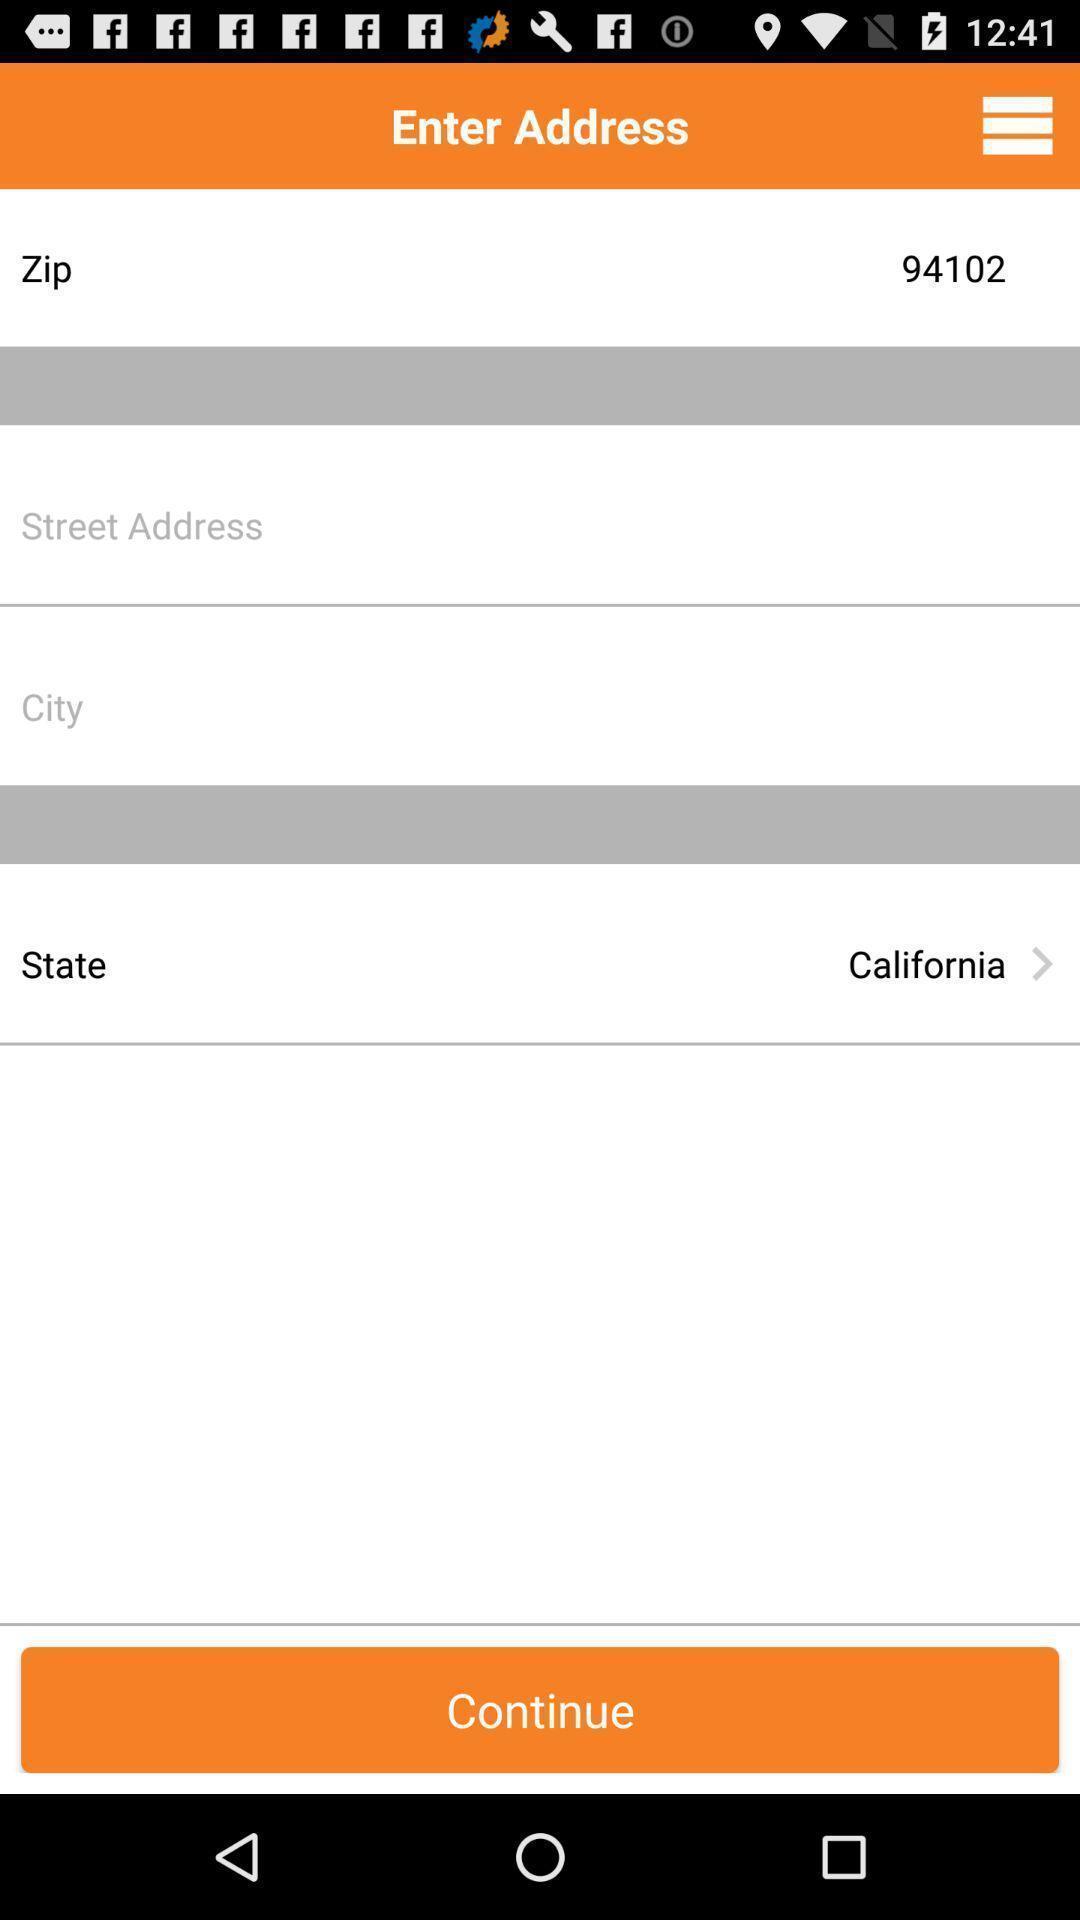Tell me what you see in this picture. Zip code and state in the enter address. 